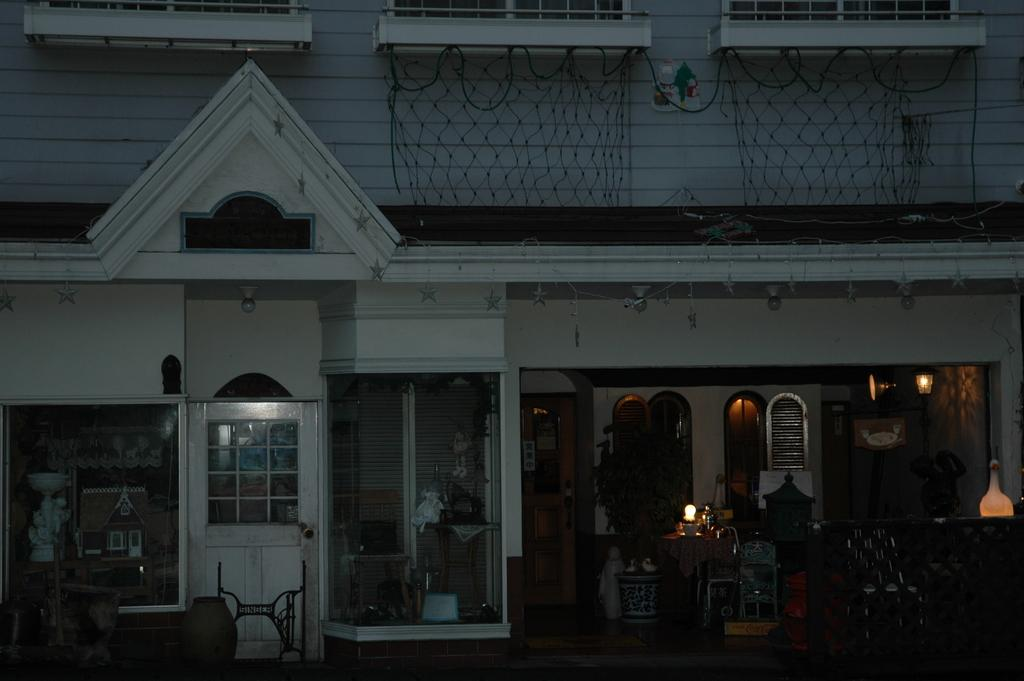What type of structure is visible in the image? There is a building in the image. What can be seen inside the building? There are glasses, windows, doors, a potted plant, lights, a net, and a chair visible in the image. Can you describe the windows in the image? There are windows in the image, but their specific characteristics are not mentioned in the provided facts. What other objects are present in the image? There are other objects in the image, but their specific details are not mentioned in the provided facts. What type of soap is being used to clean the windows in the image? There is no mention of soap or window cleaning in the provided facts, so it cannot be determined from the image. What type of badge is the person wearing in the image? There is no person or badge mentioned in the provided facts, so it cannot be determined from the image. 